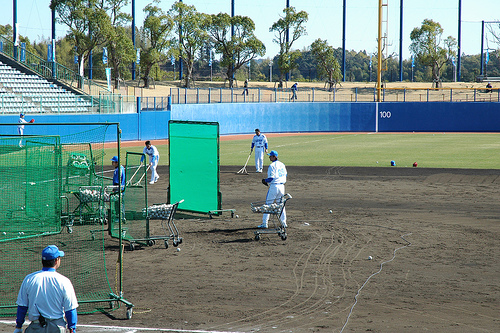<image>
Is the player on the ground? Yes. Looking at the image, I can see the player is positioned on top of the ground, with the ground providing support. Is there a walkie talkie on the baseball uniform? No. The walkie talkie is not positioned on the baseball uniform. They may be near each other, but the walkie talkie is not supported by or resting on top of the baseball uniform. 